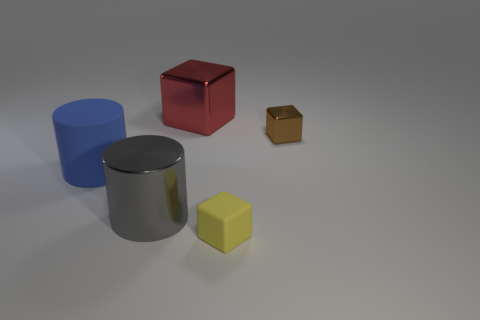The small block that is in front of the small object that is right of the matte thing that is to the right of the big matte cylinder is what color?
Your answer should be very brief. Yellow. Do the shiny cylinder and the big metallic block have the same color?
Your answer should be very brief. No. What number of objects are left of the tiny metallic thing and right of the large gray cylinder?
Keep it short and to the point. 2. How many shiny objects are red things or red balls?
Ensure brevity in your answer.  1. What material is the big thing that is behind the big blue thing that is on the left side of the metallic cylinder?
Offer a very short reply. Metal. There is a blue thing that is the same size as the gray cylinder; what shape is it?
Ensure brevity in your answer.  Cylinder. Are there fewer yellow cubes than big brown metallic cylinders?
Provide a short and direct response. No. Are there any objects that are to the left of the red metallic cube that is on the right side of the gray shiny cylinder?
Make the answer very short. Yes. What shape is the gray object that is the same material as the tiny brown object?
Your response must be concise. Cylinder. What material is the other small yellow thing that is the same shape as the tiny metallic thing?
Offer a very short reply. Rubber. 